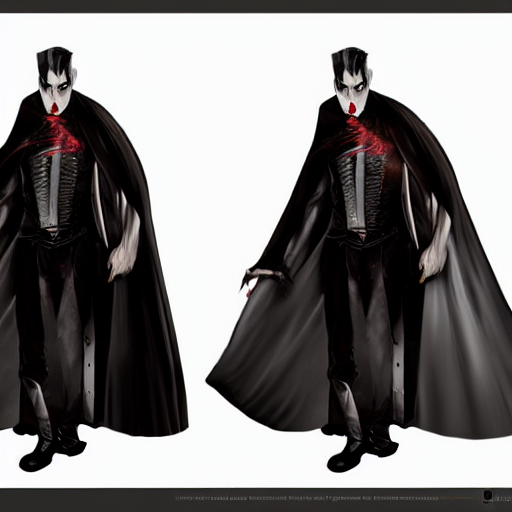How is the focus in the image?
A. Out-of-focus with noticeable noise.
B. Clear focus with no obvious noise.
C. Blurred focus with no noise. The focus in the image is crisp and clear, with the subject appearing in sharp detail against the background. There is no evidence of blurring or noise disturbances, ensuring that the visual elements are well-defined and the textures, especially in the clothing and the skin, come through vibrantly. Therefore, the correct answer is B: Clear focus with no obvious noise. 